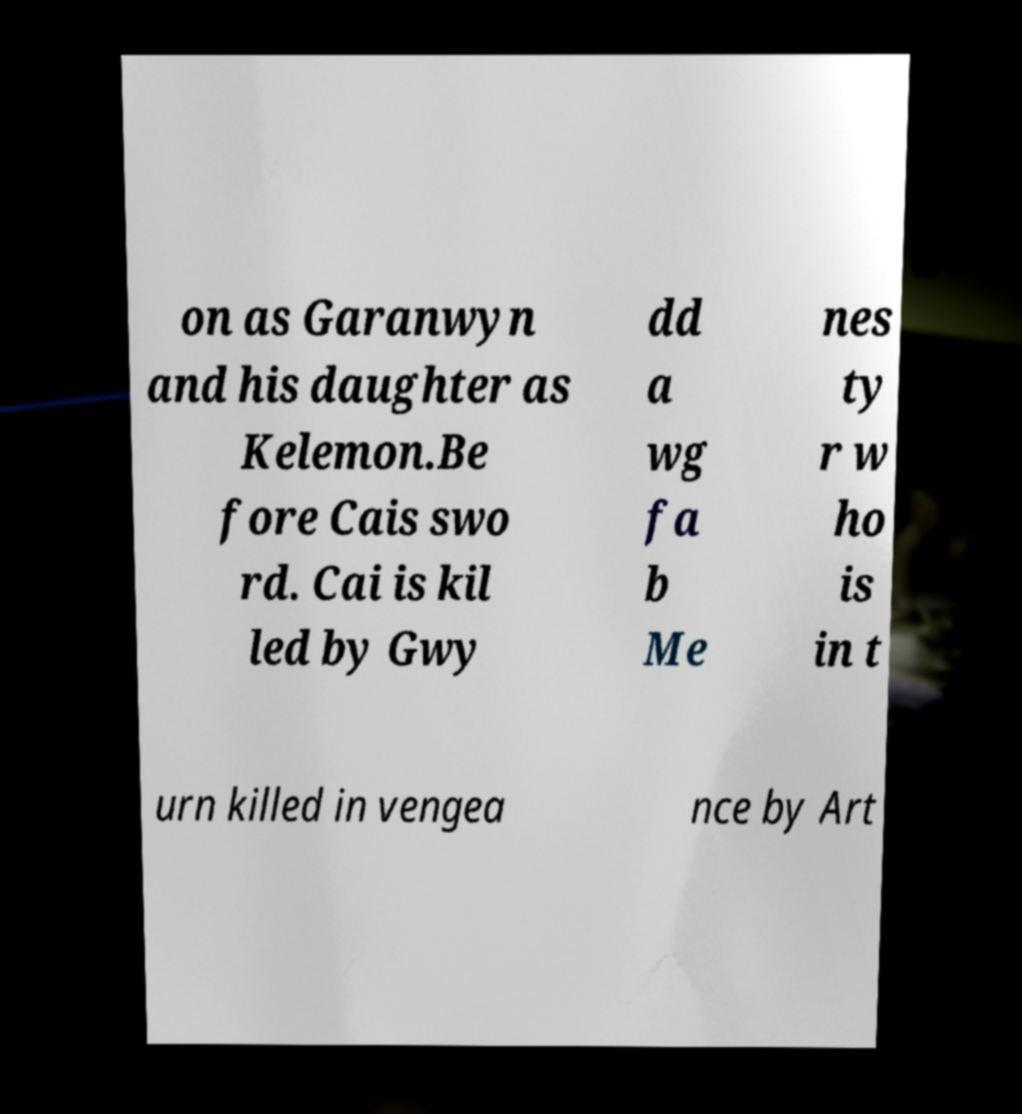Can you accurately transcribe the text from the provided image for me? on as Garanwyn and his daughter as Kelemon.Be fore Cais swo rd. Cai is kil led by Gwy dd a wg fa b Me nes ty r w ho is in t urn killed in vengea nce by Art 